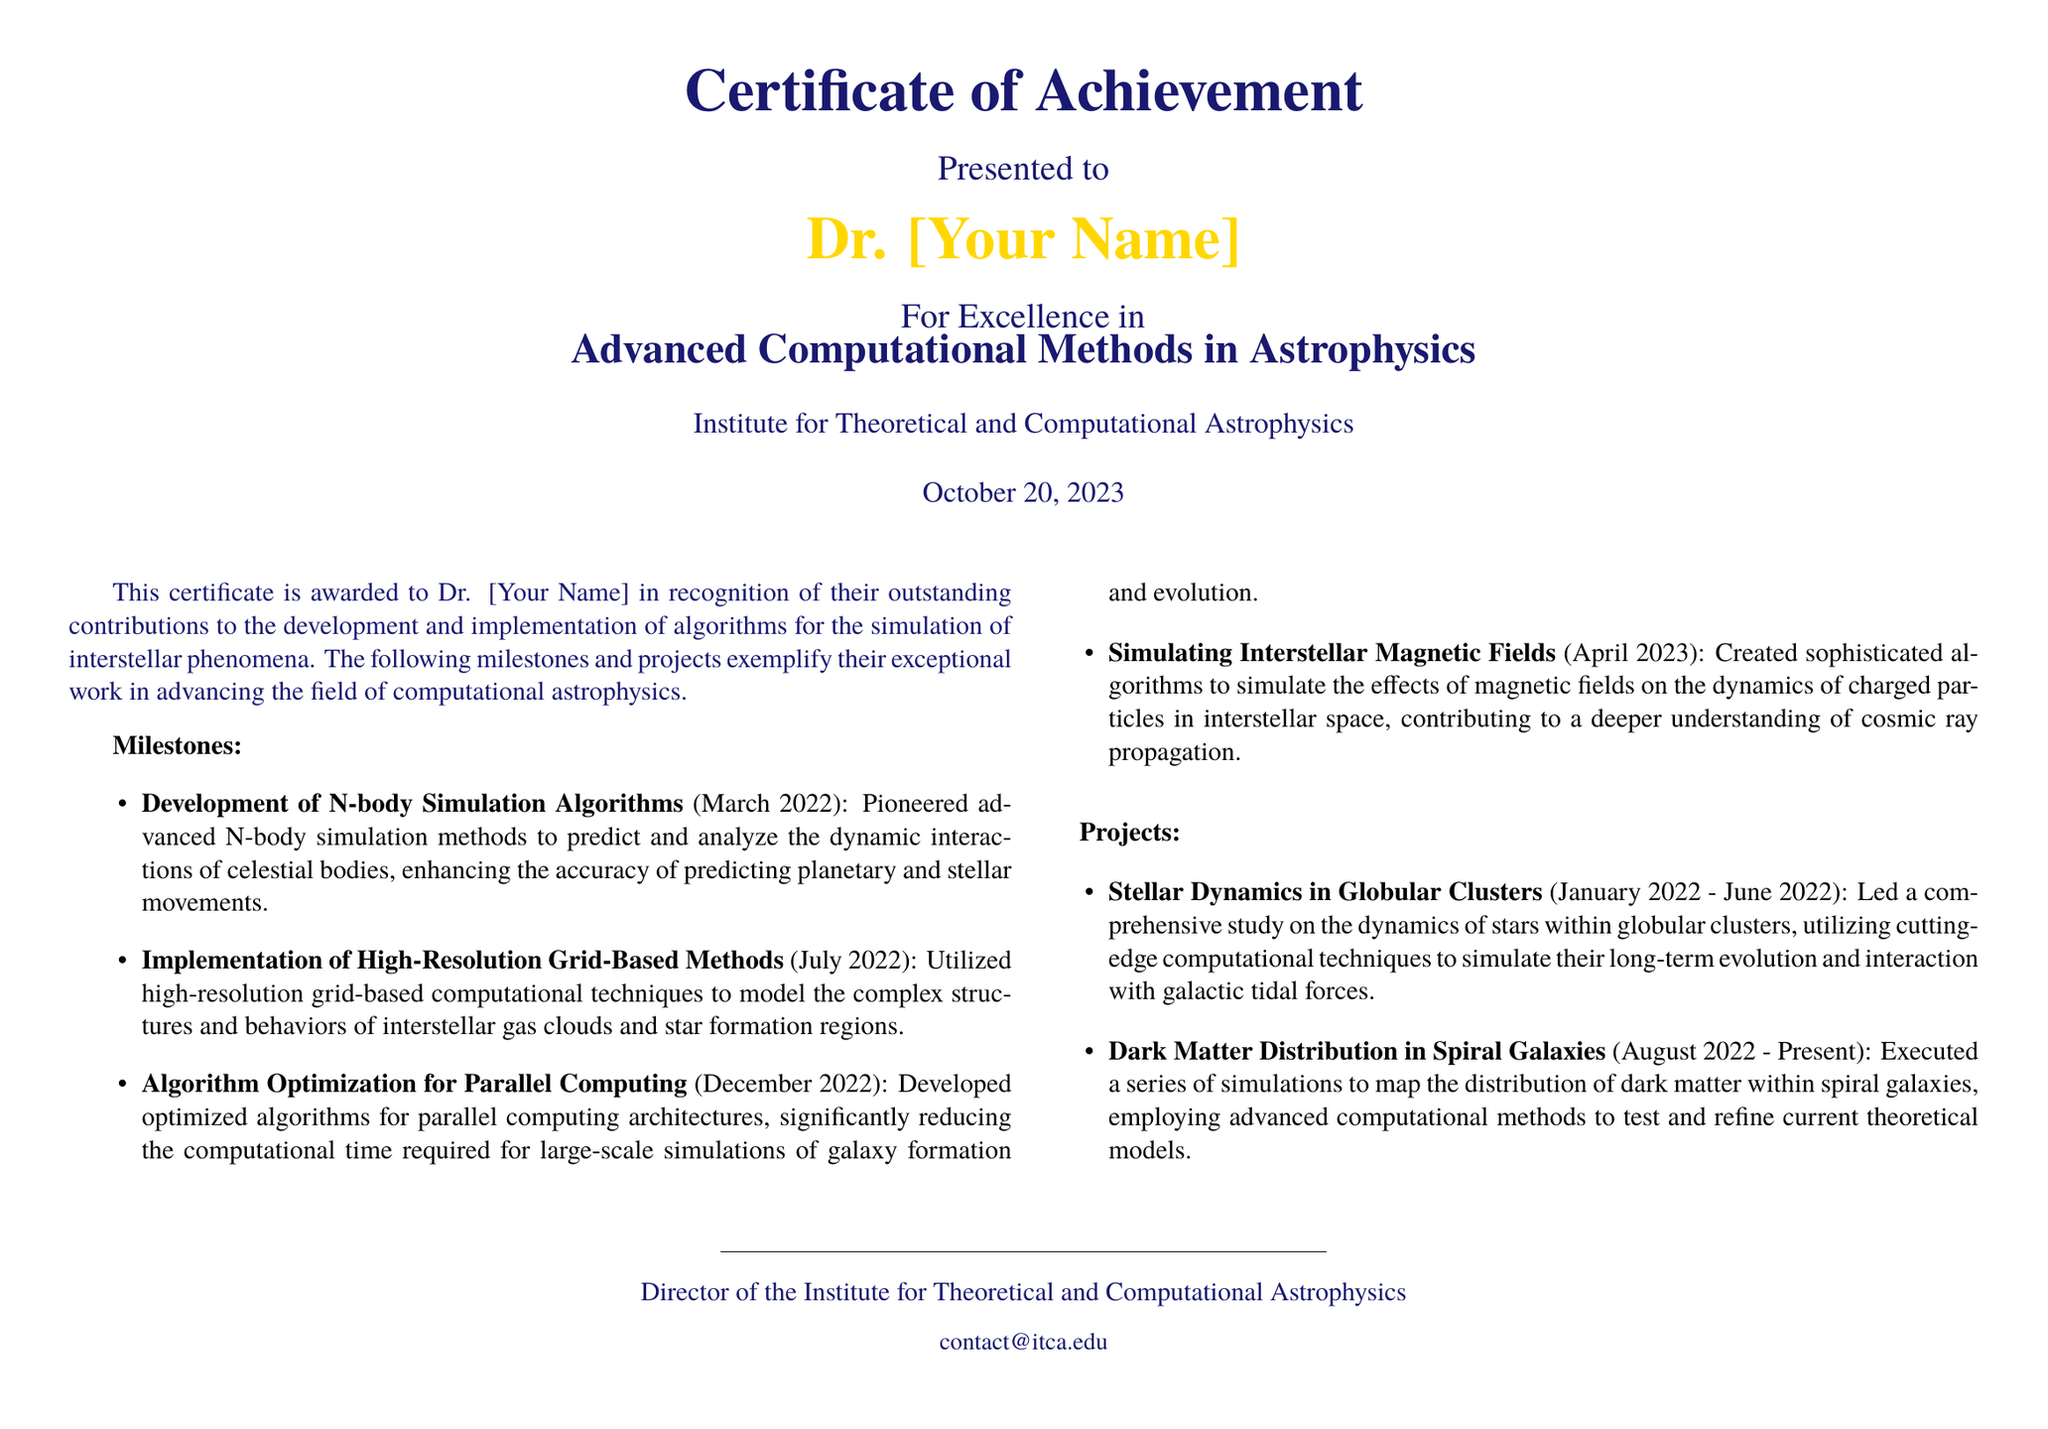What is the title of the certificate? The title of the certificate states the achievement of the recipient in a specific field, which is "Certificate of Achievement for Advanced Computational Methods in Astrophysics."
Answer: Certificate of Achievement for Advanced Computational Methods in Astrophysics Who is the certificate presented to? The document explicitly mentions the recipient's name, indicated as "Dr. [Your Name]."
Answer: Dr. [Your Name] When was the certificate awarded? The document states the award date as October 20, 2023.
Answer: October 20, 2023 What was one of the milestones achieved in March 2022? The bullet point detail under milestones specifies that advanced N-body simulation methods were developed to predict celestial dynamics.
Answer: Development of N-body Simulation Algorithms How long did the project on Dark Matter Distribution in Spiral Galaxies last? The project timeline spans from August 2022 to the present, indicating ongoing work.
Answer: August 2022 - Present How many milestones are listed in the document? The milestones section contains a total of four distinct achievements mentioned.
Answer: Four What is one of the projects completed in 2022? The document includes a project titled "Stellar Dynamics in Globular Clusters," which was conducted from January 2022 to June 2022.
Answer: Stellar Dynamics in Globular Clusters What type of algorithms were developed for parallel computing? The document describes that algorithms were optimized specifically for parallel computing architectures.
Answer: Optimized algorithms for parallel computing Who signed the certificate? The certificate is signed by the "Director of the Institute for Theoretical and Computational Astrophysics."
Answer: Director of the Institute for Theoretical and Computational Astrophysics 